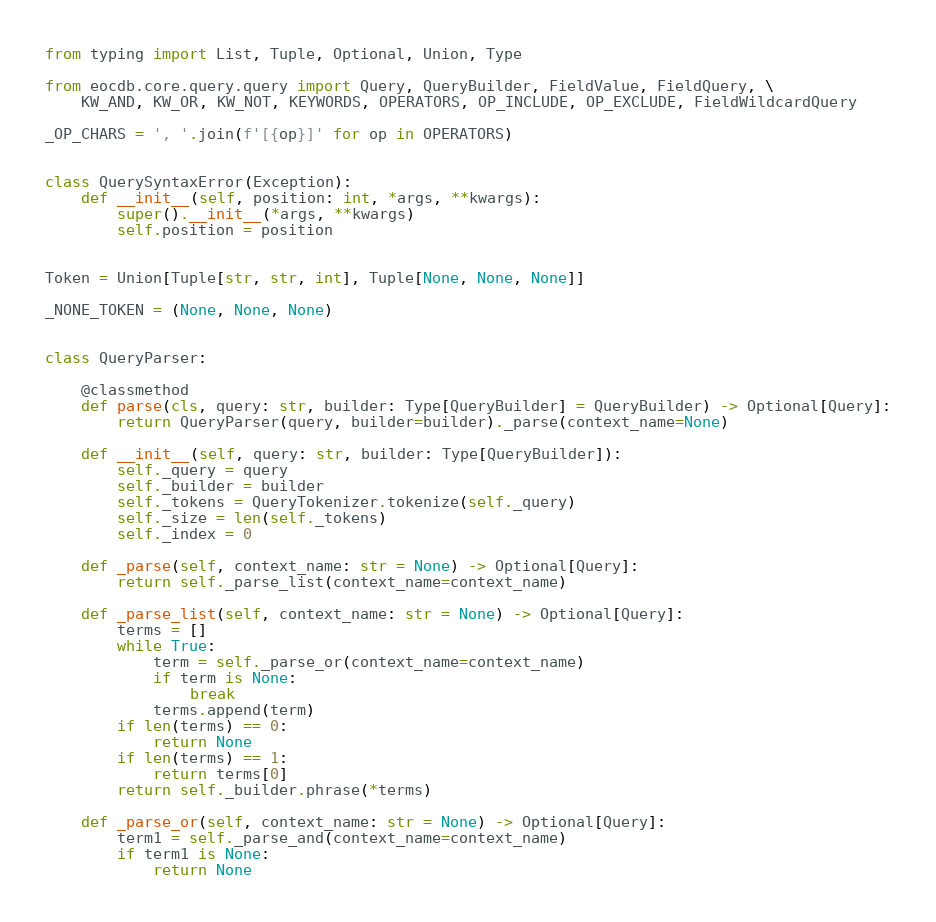<code> <loc_0><loc_0><loc_500><loc_500><_Python_>from typing import List, Tuple, Optional, Union, Type

from eocdb.core.query.query import Query, QueryBuilder, FieldValue, FieldQuery, \
    KW_AND, KW_OR, KW_NOT, KEYWORDS, OPERATORS, OP_INCLUDE, OP_EXCLUDE, FieldWildcardQuery

_OP_CHARS = ', '.join(f'[{op}]' for op in OPERATORS)


class QuerySyntaxError(Exception):
    def __init__(self, position: int, *args, **kwargs):
        super().__init__(*args, **kwargs)
        self.position = position


Token = Union[Tuple[str, str, int], Tuple[None, None, None]]

_NONE_TOKEN = (None, None, None)


class QueryParser:

    @classmethod
    def parse(cls, query: str, builder: Type[QueryBuilder] = QueryBuilder) -> Optional[Query]:
        return QueryParser(query, builder=builder)._parse(context_name=None)

    def __init__(self, query: str, builder: Type[QueryBuilder]):
        self._query = query
        self._builder = builder
        self._tokens = QueryTokenizer.tokenize(self._query)
        self._size = len(self._tokens)
        self._index = 0

    def _parse(self, context_name: str = None) -> Optional[Query]:
        return self._parse_list(context_name=context_name)

    def _parse_list(self, context_name: str = None) -> Optional[Query]:
        terms = []
        while True:
            term = self._parse_or(context_name=context_name)
            if term is None:
                break
            terms.append(term)
        if len(terms) == 0:
            return None
        if len(terms) == 1:
            return terms[0]
        return self._builder.phrase(*terms)

    def _parse_or(self, context_name: str = None) -> Optional[Query]:
        term1 = self._parse_and(context_name=context_name)
        if term1 is None:
            return None</code> 